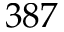Convert formula to latex. <formula><loc_0><loc_0><loc_500><loc_500>3 8 7</formula> 